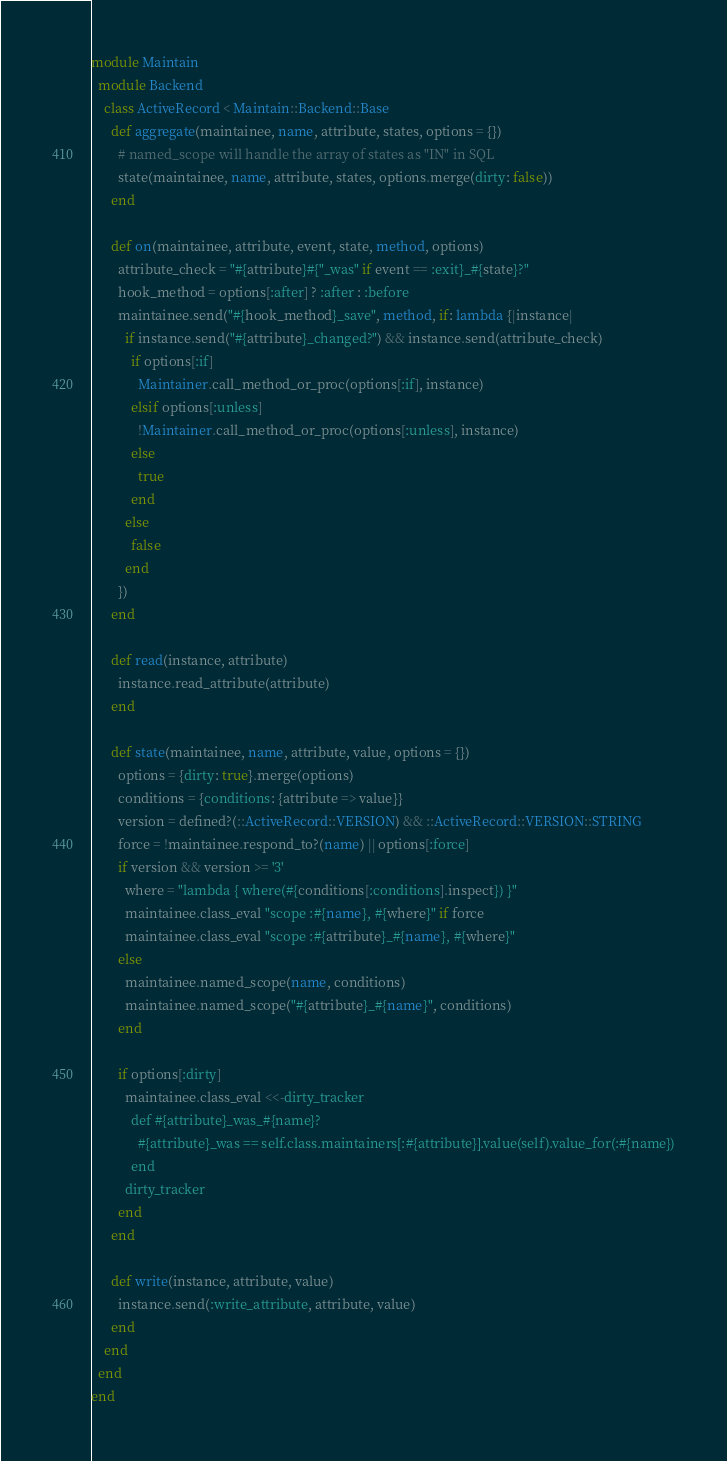Convert code to text. <code><loc_0><loc_0><loc_500><loc_500><_Ruby_>module Maintain
  module Backend
    class ActiveRecord < Maintain::Backend::Base
      def aggregate(maintainee, name, attribute, states, options = {})
        # named_scope will handle the array of states as "IN" in SQL
        state(maintainee, name, attribute, states, options.merge(dirty: false))
      end

      def on(maintainee, attribute, event, state, method, options)
        attribute_check = "#{attribute}#{"_was" if event == :exit}_#{state}?"
        hook_method = options[:after] ? :after : :before
        maintainee.send("#{hook_method}_save", method, if: lambda {|instance|
          if instance.send("#{attribute}_changed?") && instance.send(attribute_check)
            if options[:if]
              Maintainer.call_method_or_proc(options[:if], instance)
            elsif options[:unless]
              !Maintainer.call_method_or_proc(options[:unless], instance)
            else
              true
            end
          else
            false
          end
        })
      end

      def read(instance, attribute)
        instance.read_attribute(attribute)
      end

      def state(maintainee, name, attribute, value, options = {})
        options = {dirty: true}.merge(options)
        conditions = {conditions: {attribute => value}}
        version = defined?(::ActiveRecord::VERSION) && ::ActiveRecord::VERSION::STRING
        force = !maintainee.respond_to?(name) || options[:force]
        if version && version >= '3'
          where = "lambda { where(#{conditions[:conditions].inspect}) }"
          maintainee.class_eval "scope :#{name}, #{where}" if force
          maintainee.class_eval "scope :#{attribute}_#{name}, #{where}"
        else
          maintainee.named_scope(name, conditions)
          maintainee.named_scope("#{attribute}_#{name}", conditions)
        end

        if options[:dirty]
          maintainee.class_eval <<-dirty_tracker
            def #{attribute}_was_#{name}?
              #{attribute}_was == self.class.maintainers[:#{attribute}].value(self).value_for(:#{name})
            end
          dirty_tracker
        end
      end

      def write(instance, attribute, value)
        instance.send(:write_attribute, attribute, value)
      end
    end
  end
end
</code> 